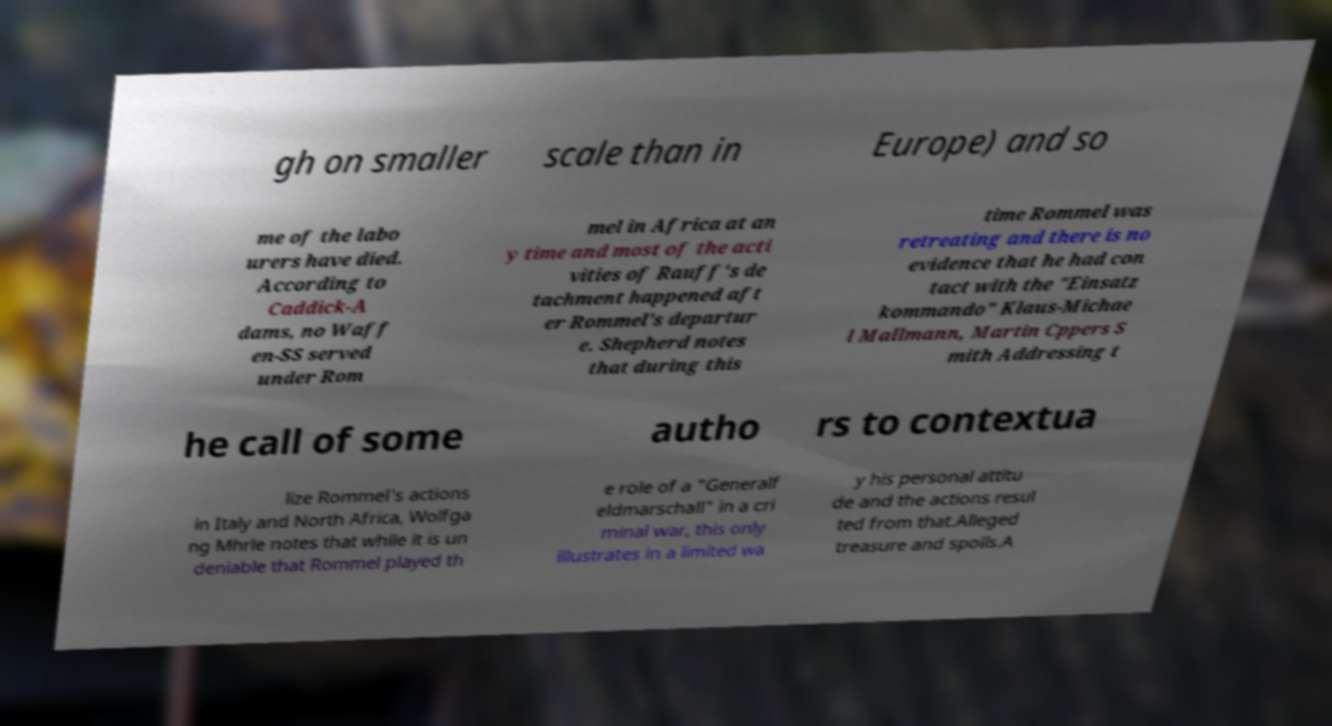There's text embedded in this image that I need extracted. Can you transcribe it verbatim? gh on smaller scale than in Europe) and so me of the labo urers have died. According to Caddick-A dams, no Waff en-SS served under Rom mel in Africa at an y time and most of the acti vities of Rauff's de tachment happened aft er Rommel's departur e. Shepherd notes that during this time Rommel was retreating and there is no evidence that he had con tact with the "Einsatz kommando" Klaus-Michae l Mallmann, Martin Cppers S mith Addressing t he call of some autho rs to contextua lize Rommel's actions in Italy and North Africa, Wolfga ng Mhrle notes that while it is un deniable that Rommel played th e role of a "Generalf eldmarschall" in a cri minal war, this only illustrates in a limited wa y his personal attitu de and the actions resul ted from that.Alleged treasure and spoils.A 